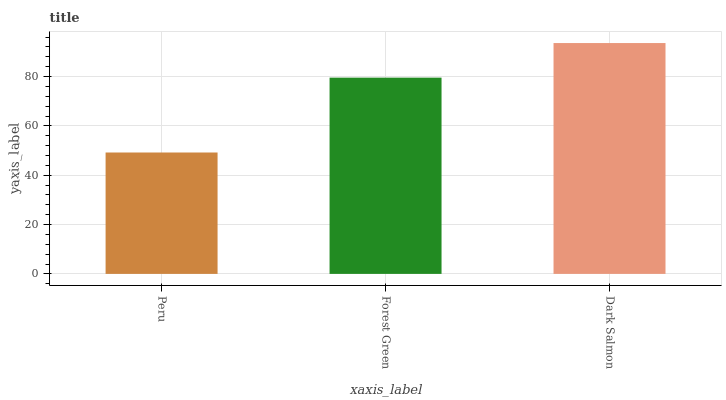Is Peru the minimum?
Answer yes or no. Yes. Is Dark Salmon the maximum?
Answer yes or no. Yes. Is Forest Green the minimum?
Answer yes or no. No. Is Forest Green the maximum?
Answer yes or no. No. Is Forest Green greater than Peru?
Answer yes or no. Yes. Is Peru less than Forest Green?
Answer yes or no. Yes. Is Peru greater than Forest Green?
Answer yes or no. No. Is Forest Green less than Peru?
Answer yes or no. No. Is Forest Green the high median?
Answer yes or no. Yes. Is Forest Green the low median?
Answer yes or no. Yes. Is Dark Salmon the high median?
Answer yes or no. No. Is Peru the low median?
Answer yes or no. No. 